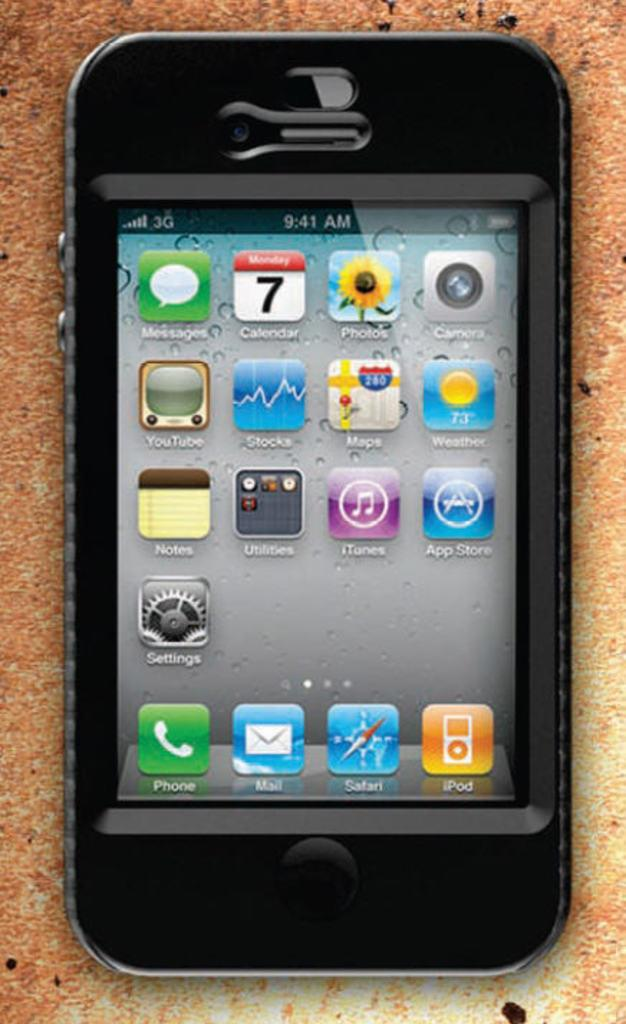<image>
Provide a brief description of the given image. a phone that has the word phone on a green icon 